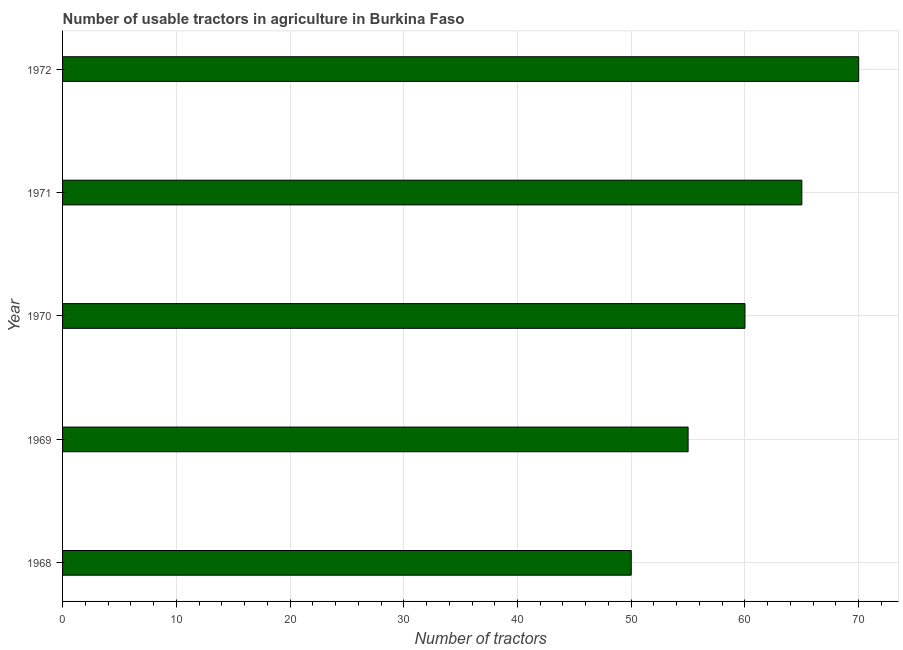What is the title of the graph?
Offer a terse response. Number of usable tractors in agriculture in Burkina Faso. What is the label or title of the X-axis?
Give a very brief answer. Number of tractors. What is the label or title of the Y-axis?
Your answer should be compact. Year. In which year was the number of tractors minimum?
Offer a terse response. 1968. What is the sum of the number of tractors?
Offer a very short reply. 300. What is the ratio of the number of tractors in 1970 to that in 1971?
Give a very brief answer. 0.92. Is the sum of the number of tractors in 1968 and 1969 greater than the maximum number of tractors across all years?
Your answer should be compact. Yes. In how many years, is the number of tractors greater than the average number of tractors taken over all years?
Provide a short and direct response. 2. How many bars are there?
Ensure brevity in your answer.  5. Are all the bars in the graph horizontal?
Provide a short and direct response. Yes. What is the Number of tractors in 1968?
Provide a succinct answer. 50. What is the Number of tractors of 1971?
Offer a very short reply. 65. What is the difference between the Number of tractors in 1968 and 1970?
Make the answer very short. -10. What is the ratio of the Number of tractors in 1968 to that in 1969?
Keep it short and to the point. 0.91. What is the ratio of the Number of tractors in 1968 to that in 1970?
Offer a very short reply. 0.83. What is the ratio of the Number of tractors in 1968 to that in 1971?
Your answer should be compact. 0.77. What is the ratio of the Number of tractors in 1968 to that in 1972?
Your response must be concise. 0.71. What is the ratio of the Number of tractors in 1969 to that in 1970?
Your response must be concise. 0.92. What is the ratio of the Number of tractors in 1969 to that in 1971?
Ensure brevity in your answer.  0.85. What is the ratio of the Number of tractors in 1969 to that in 1972?
Give a very brief answer. 0.79. What is the ratio of the Number of tractors in 1970 to that in 1971?
Your answer should be compact. 0.92. What is the ratio of the Number of tractors in 1970 to that in 1972?
Your response must be concise. 0.86. What is the ratio of the Number of tractors in 1971 to that in 1972?
Offer a very short reply. 0.93. 